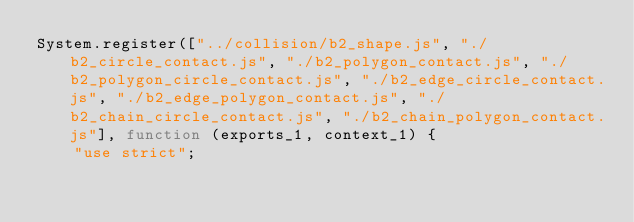<code> <loc_0><loc_0><loc_500><loc_500><_JavaScript_>System.register(["../collision/b2_shape.js", "./b2_circle_contact.js", "./b2_polygon_contact.js", "./b2_polygon_circle_contact.js", "./b2_edge_circle_contact.js", "./b2_edge_polygon_contact.js", "./b2_chain_circle_contact.js", "./b2_chain_polygon_contact.js"], function (exports_1, context_1) {
    "use strict";</code> 